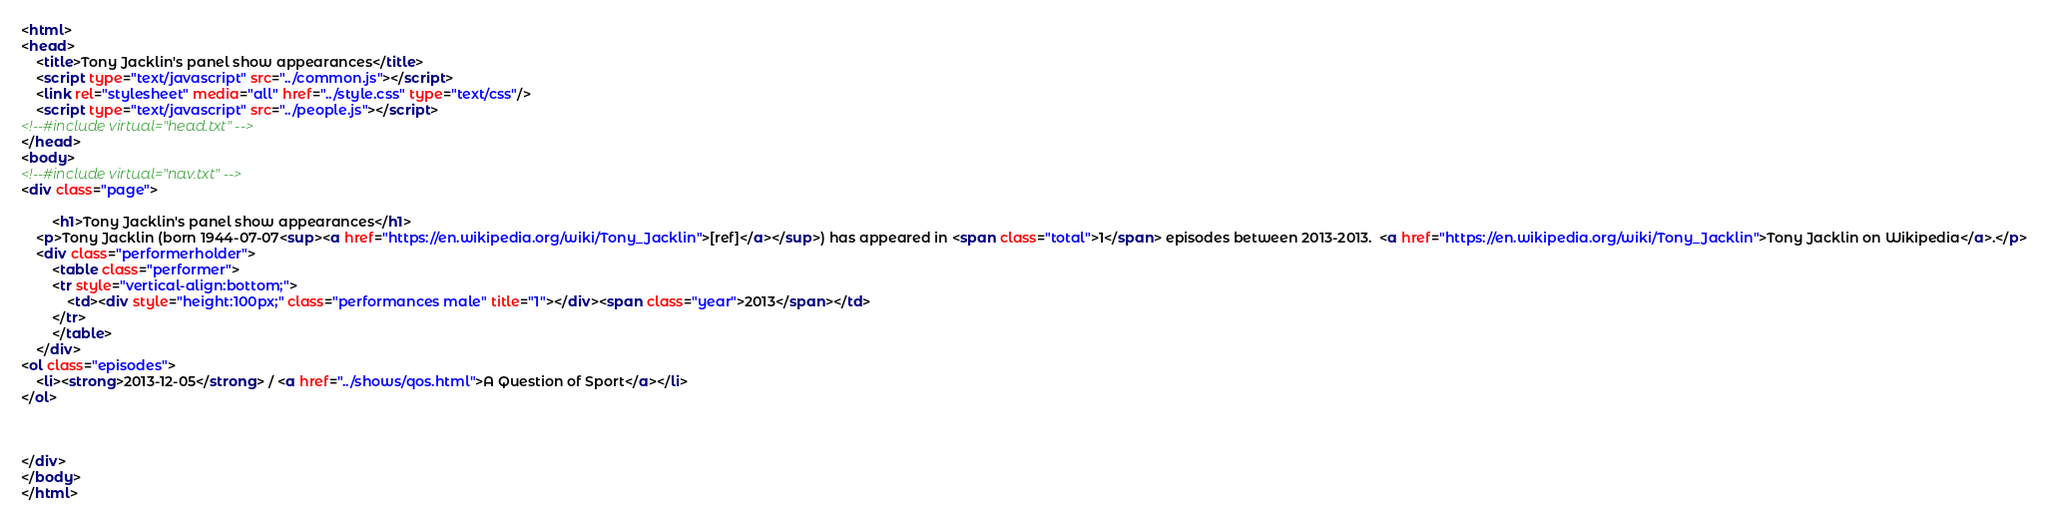<code> <loc_0><loc_0><loc_500><loc_500><_HTML_><html>
<head>
	<title>Tony Jacklin's panel show appearances</title>
	<script type="text/javascript" src="../common.js"></script>
	<link rel="stylesheet" media="all" href="../style.css" type="text/css"/>
	<script type="text/javascript" src="../people.js"></script>
<!--#include virtual="head.txt" -->
</head>
<body>
<!--#include virtual="nav.txt" -->
<div class="page">

		<h1>Tony Jacklin's panel show appearances</h1>
	<p>Tony Jacklin (born 1944-07-07<sup><a href="https://en.wikipedia.org/wiki/Tony_Jacklin">[ref]</a></sup>) has appeared in <span class="total">1</span> episodes between 2013-2013.  <a href="https://en.wikipedia.org/wiki/Tony_Jacklin">Tony Jacklin on Wikipedia</a>.</p>
	<div class="performerholder">
		<table class="performer">
		<tr style="vertical-align:bottom;">
			<td><div style="height:100px;" class="performances male" title="1"></div><span class="year">2013</span></td>
		</tr>
		</table>
	</div>
<ol class="episodes">
	<li><strong>2013-12-05</strong> / <a href="../shows/qos.html">A Question of Sport</a></li>
</ol>



</div>
</body>
</html>
</code> 